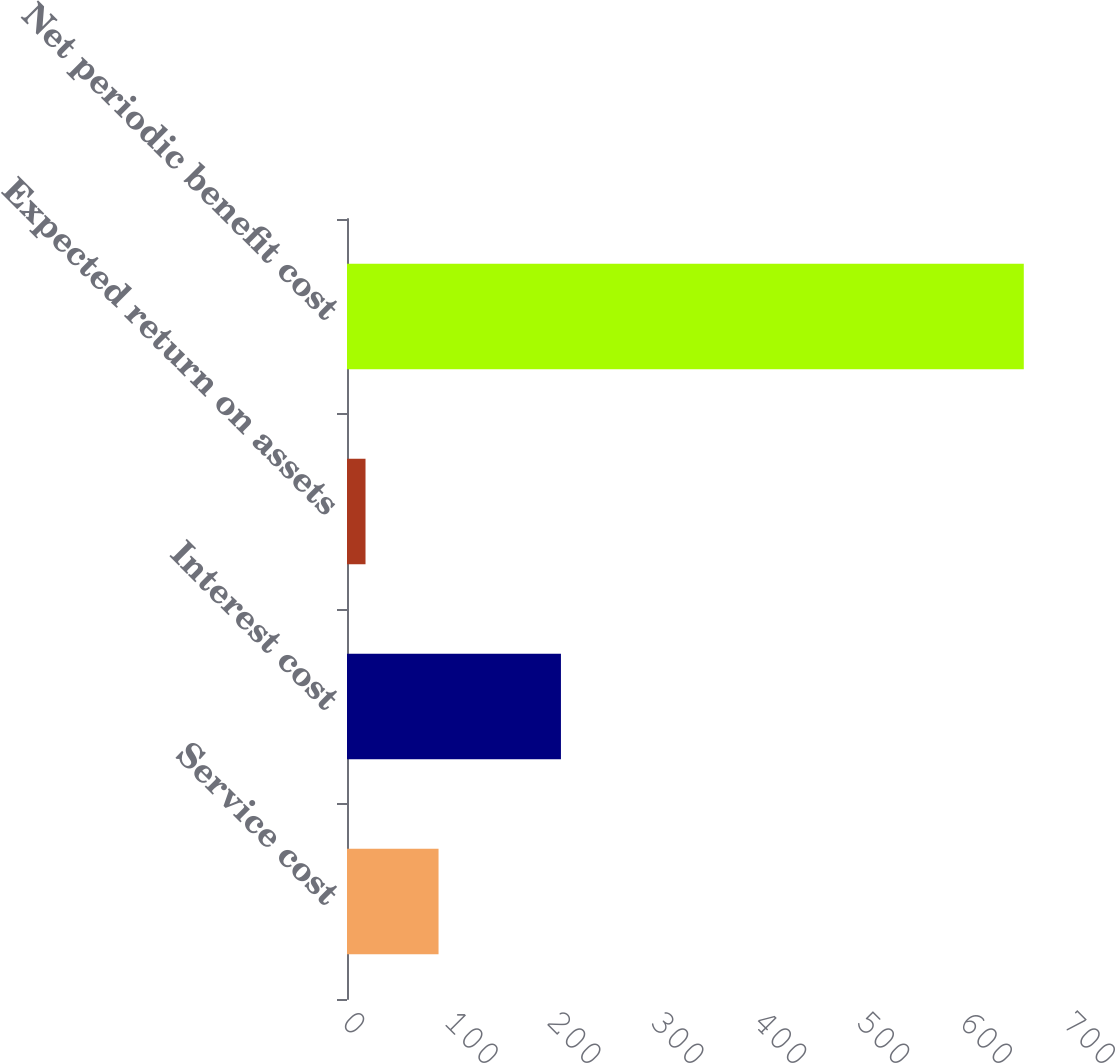Convert chart to OTSL. <chart><loc_0><loc_0><loc_500><loc_500><bar_chart><fcel>Service cost<fcel>Interest cost<fcel>Expected return on assets<fcel>Net periodic benefit cost<nl><fcel>89<fcel>208<fcel>18<fcel>658<nl></chart> 